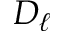Convert formula to latex. <formula><loc_0><loc_0><loc_500><loc_500>D _ { \ell }</formula> 